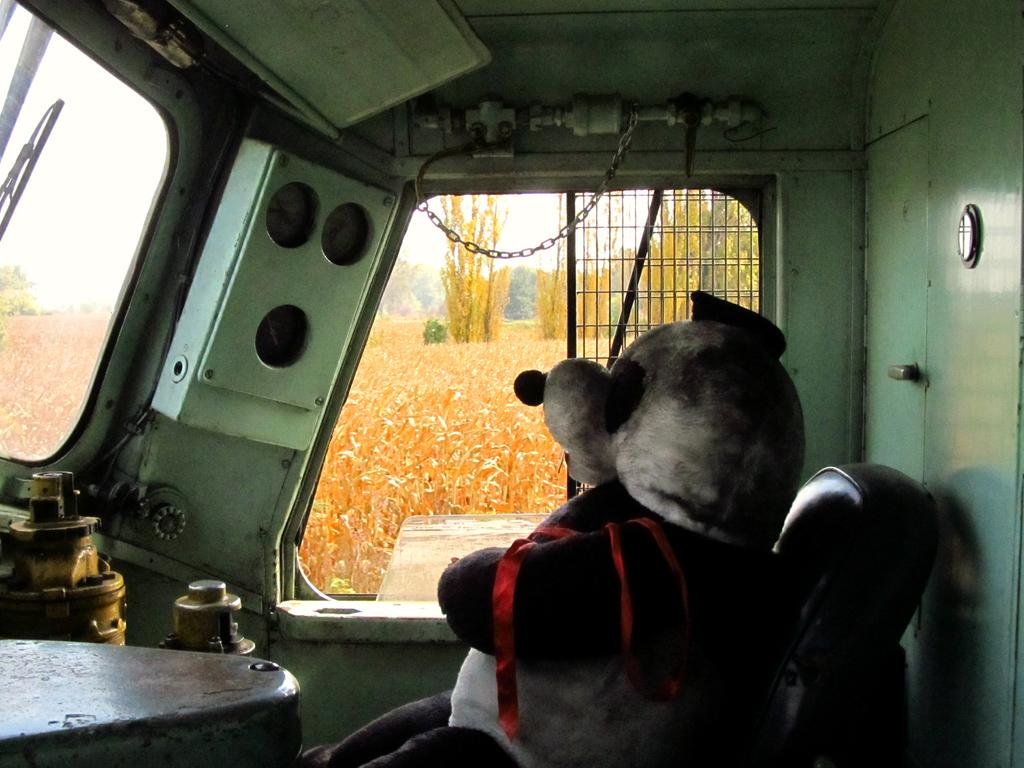What is on the chair in the image? There is a soft toy on a chair in the image. Where is the chair located? The chair is on a vehicle. What can be seen in the background of the image? There are plants, trees, and the sky visible in the background of the image. What type of cakes are being served to the family in the aftermath of the event? There is no mention of cakes, family, or an event in the image, so it is not possible to answer this question. 